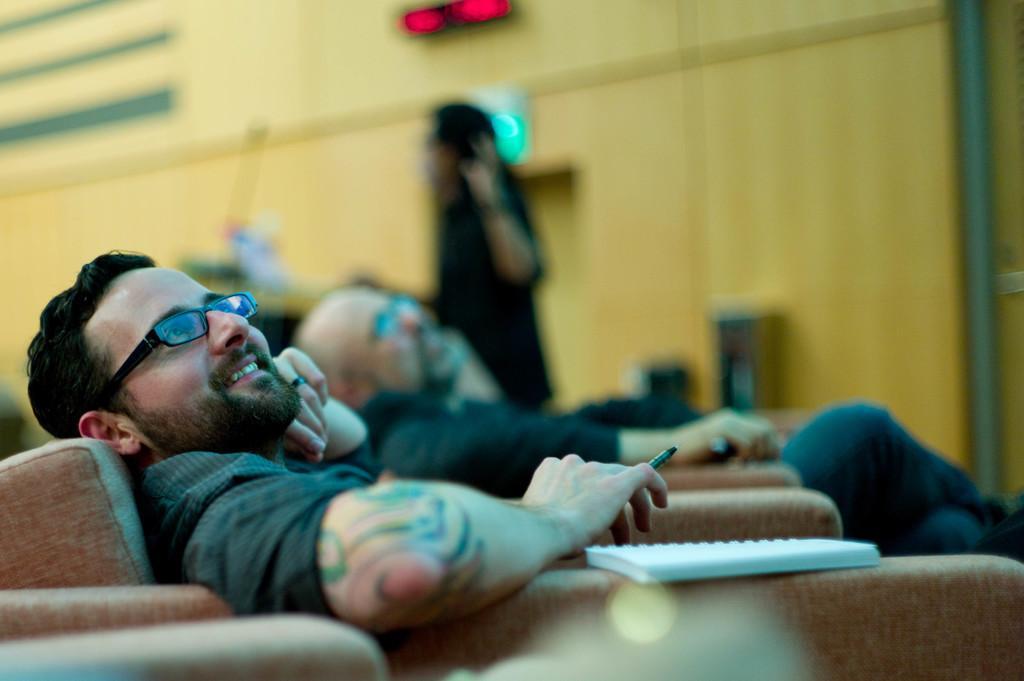Could you give a brief overview of what you see in this image? In this image we can see people sitting on chairs. There is a book on the chair. In the background of the image there is wall. There is a person standing. 